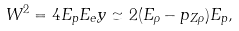<formula> <loc_0><loc_0><loc_500><loc_500>W ^ { 2 } = 4 E _ { p } E _ { e } y \simeq 2 ( E _ { \rho } - p _ { Z \rho } ) E _ { p } ,</formula> 